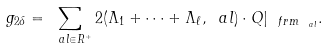Convert formula to latex. <formula><loc_0><loc_0><loc_500><loc_500>g _ { 2 \delta } = \sum _ { \ a l \in R ^ { + } } 2 ( \Lambda _ { 1 } + \cdots + \Lambda _ { \ell } , \ a l ) \cdot Q | _ { \ f r { m } _ { \ a l } } .</formula> 